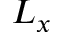<formula> <loc_0><loc_0><loc_500><loc_500>L _ { x }</formula> 